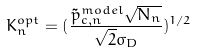<formula> <loc_0><loc_0><loc_500><loc_500>K _ { n } ^ { o p t } = ( \frac { \tilde { p } _ { c , n } ^ { m o d e l } \sqrt { N _ { n } } } { \sqrt { 2 } \sigma _ { D } } ) ^ { 1 / 2 }</formula> 